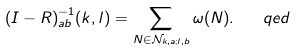<formula> <loc_0><loc_0><loc_500><loc_500>( I - R ) _ { a b } ^ { - 1 } ( k , l ) = \sum _ { N \in \mathcal { N } _ { k , a ; l , b } } \omega ( N ) . \quad q e d</formula> 